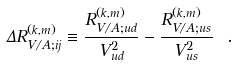<formula> <loc_0><loc_0><loc_500><loc_500>\Delta R ^ { ( k , m ) } _ { V / A ; i j } \equiv \frac { R ^ { ( k , m ) } _ { V / A ; u d } } { V _ { u d } ^ { 2 } } - { \frac { R ^ { ( k , m ) } _ { V / A ; u s } } { V _ { u s } ^ { 2 } } } \ .</formula> 